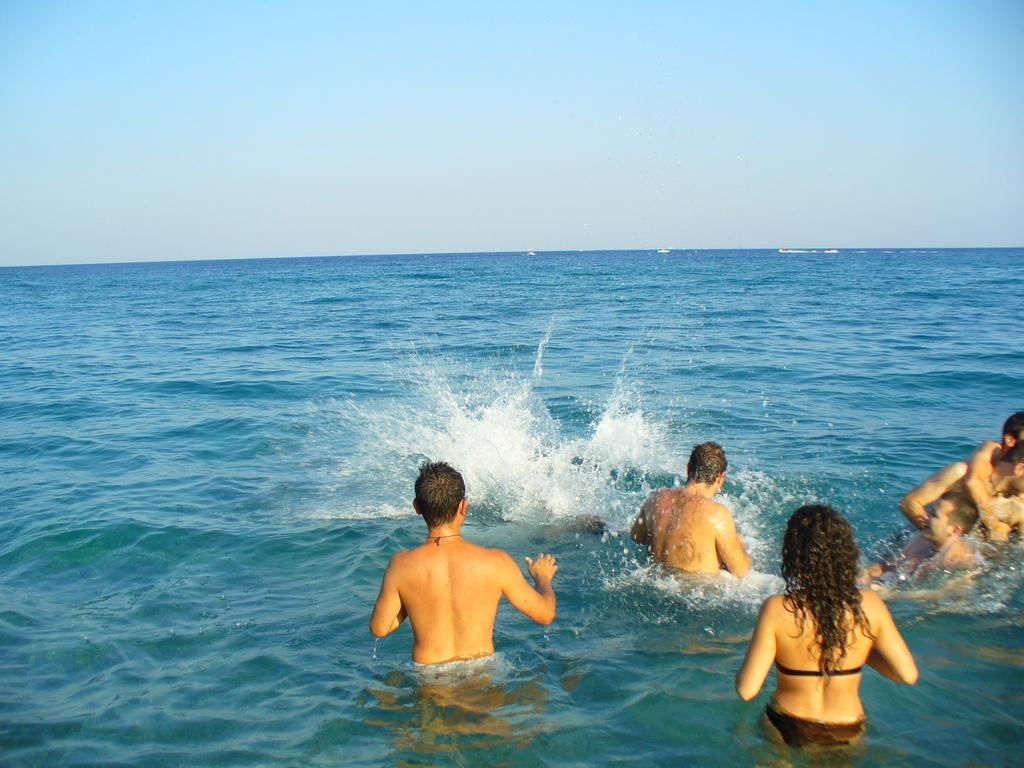What is happening in the image involving the group of people? The group of men and women is playing and enjoying in the seawater. What type of environment is depicted in the image? The image shows a scene with sea water visible. What is the condition of the sky in the image? The sky is clear and blue in the image. What type of coat is being worn by the society in the image? There is no mention of a coat or society in the image; it features a group of people playing in the seawater. What company is responsible for organizing the event in the image? There is no indication of an organized event or company involvement in the image. 